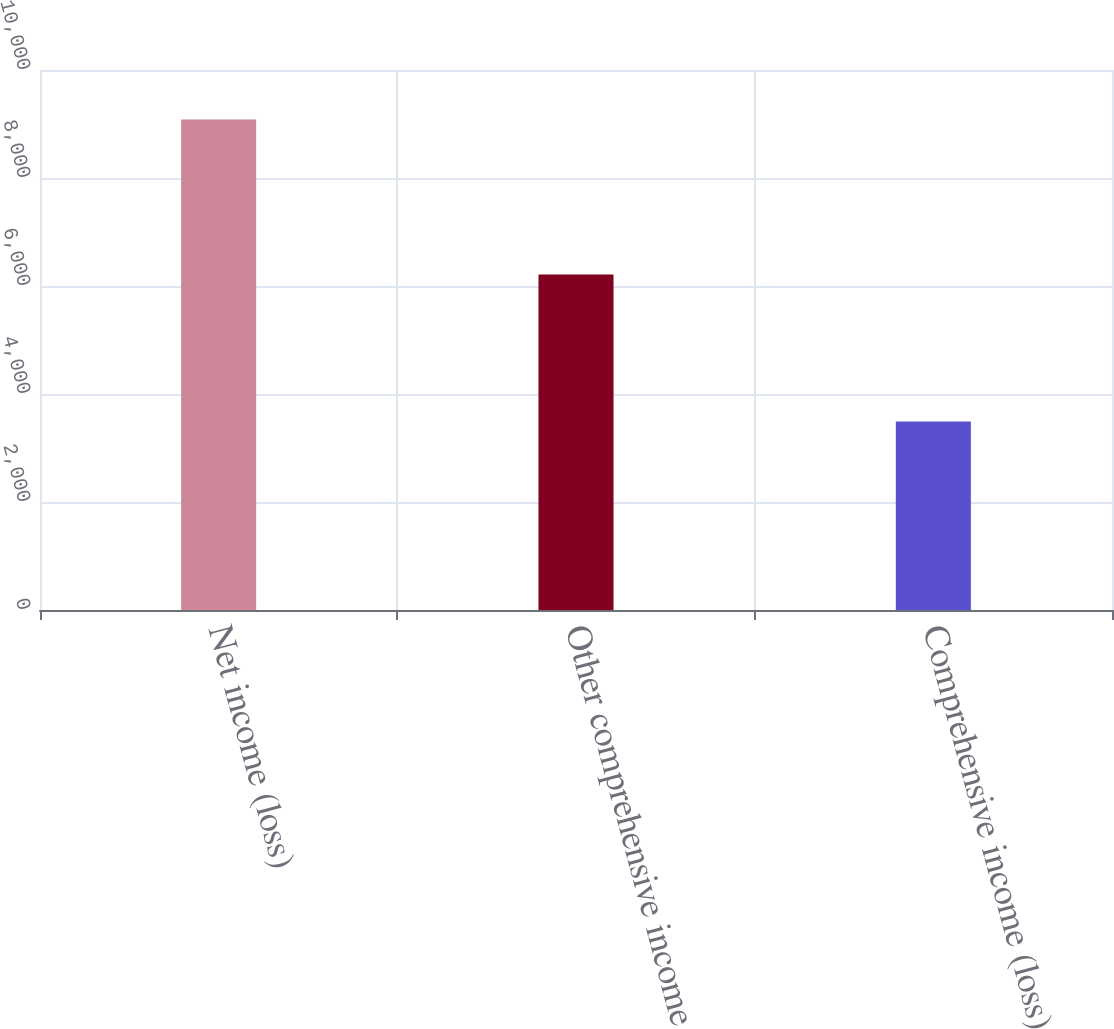Convert chart. <chart><loc_0><loc_0><loc_500><loc_500><bar_chart><fcel>Net income (loss)<fcel>Other comprehensive income<fcel>Comprehensive income (loss)<nl><fcel>9085<fcel>6214<fcel>3492.4<nl></chart> 